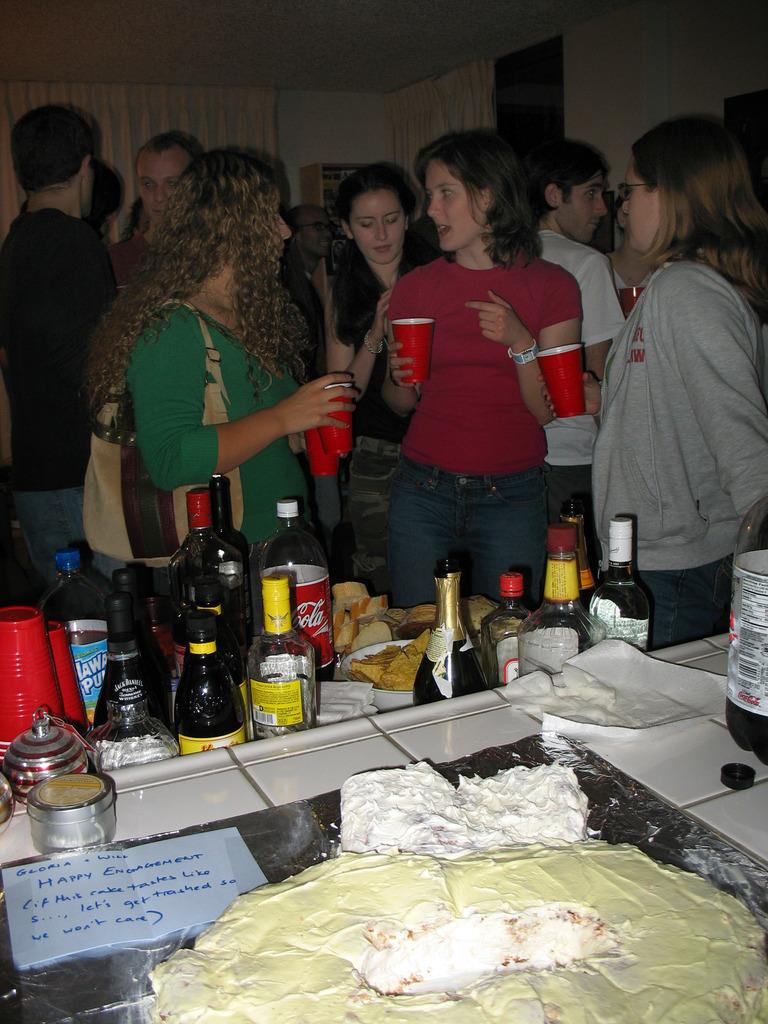What is happening in the image involving a group of people? There is a group of people in the image, and they are holding glasses. What else can be seen in the image related to the group of people? There are wine bottles in the image. Are there any other food items visible in the image? Yes, there are other food items in the image. Where is the cake located in the image? There is no cake present in the image. Is there a bomb visible in the image? No, there is no bomb present in the image. 